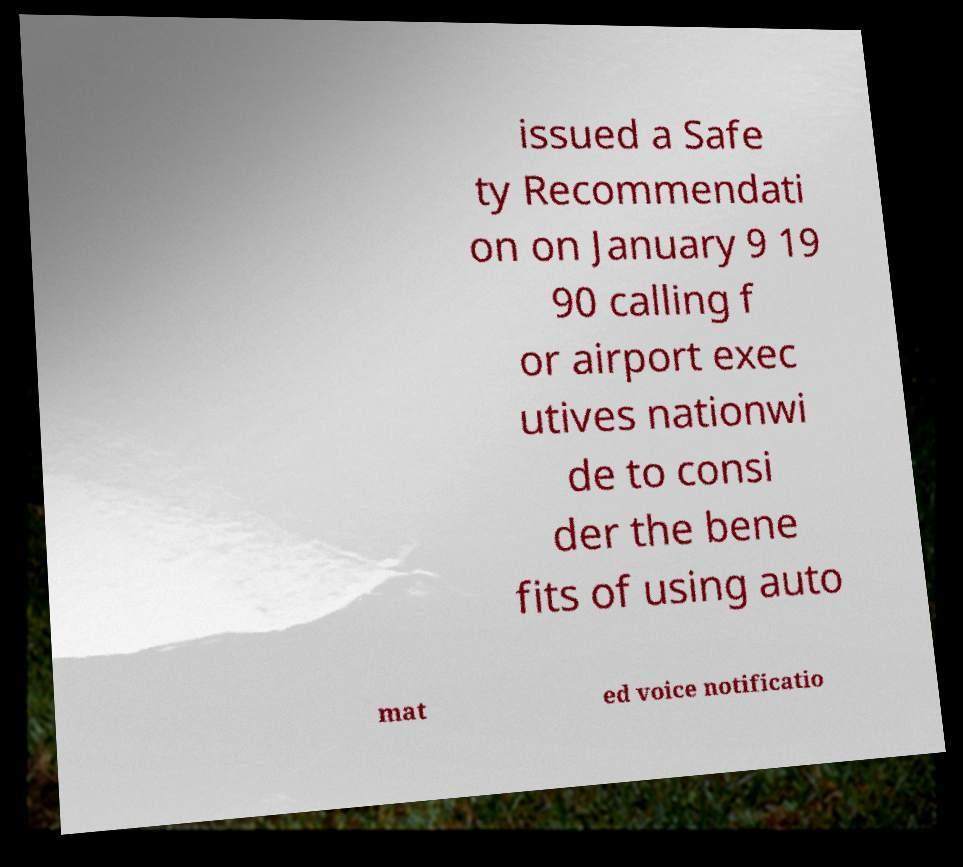What messages or text are displayed in this image? I need them in a readable, typed format. issued a Safe ty Recommendati on on January 9 19 90 calling f or airport exec utives nationwi de to consi der the bene fits of using auto mat ed voice notificatio 